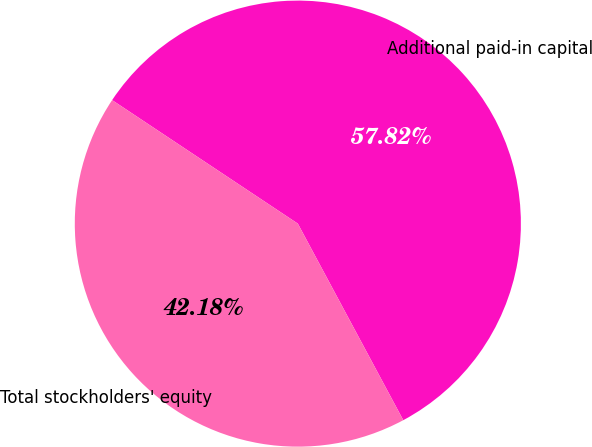Convert chart to OTSL. <chart><loc_0><loc_0><loc_500><loc_500><pie_chart><fcel>Additional paid-in capital<fcel>Total stockholders' equity<nl><fcel>57.82%<fcel>42.18%<nl></chart> 